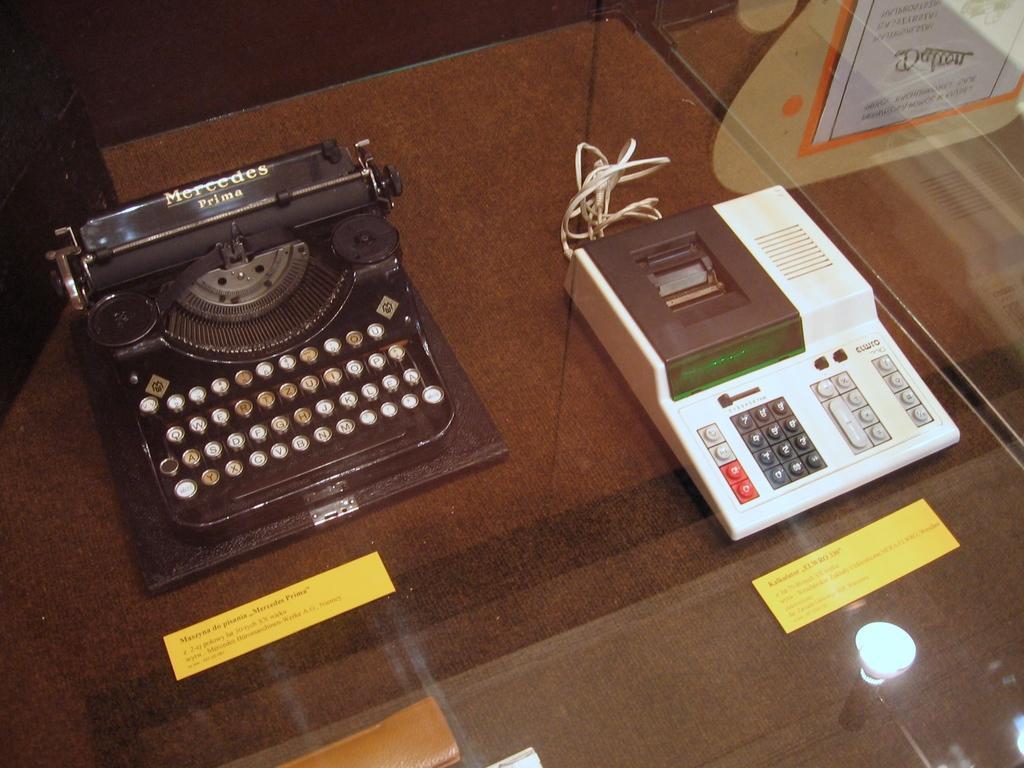Please provide a concise description of this image. In this picture there are objects and there are papers on the glass and there is text on the glass and there is reflection of light on the glass. At the back there is a poster behind the glass and there is text on the poster. 